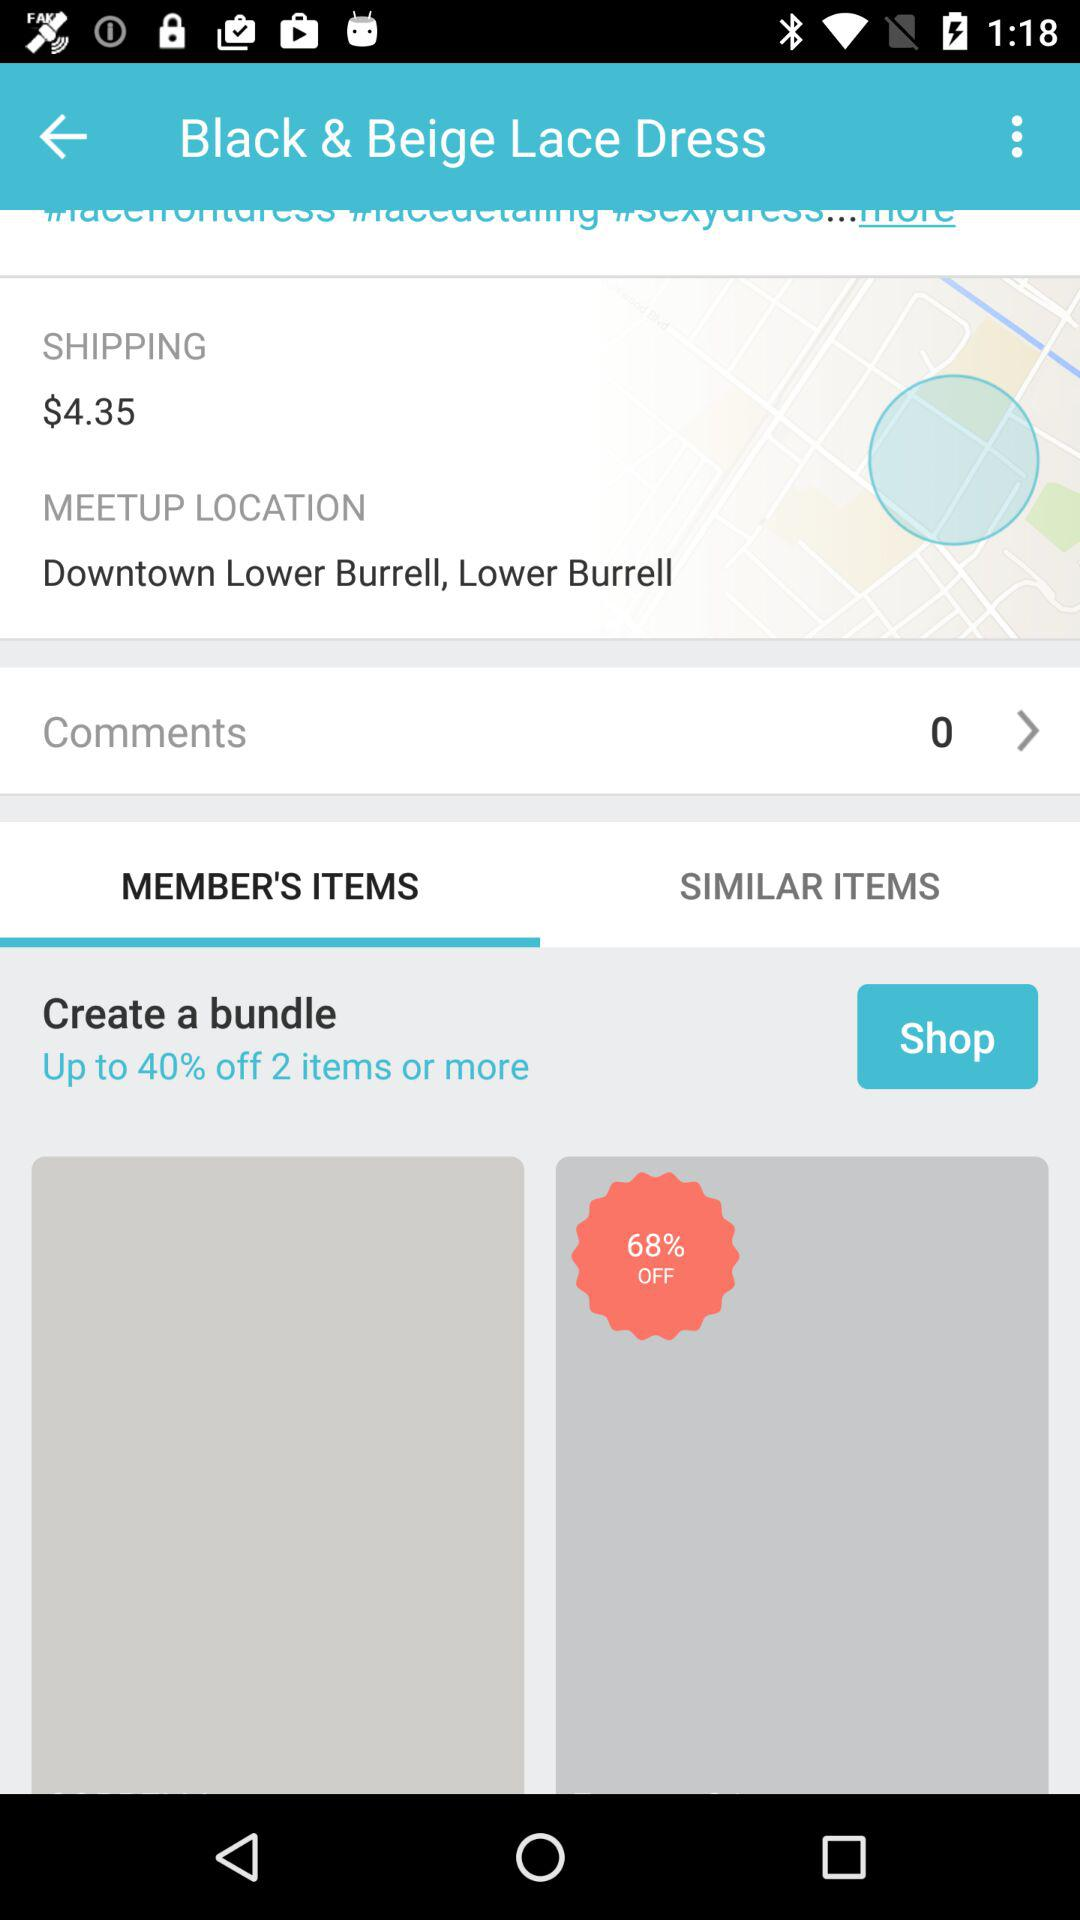Which tab is selected? The selected tab is "MEMBER'S ITEMS". 